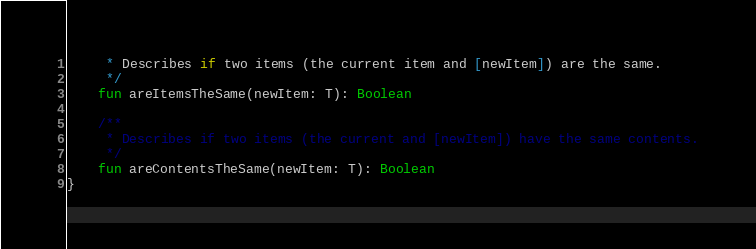<code> <loc_0><loc_0><loc_500><loc_500><_Kotlin_>     * Describes if two items (the current item and [newItem]) are the same.
     */
    fun areItemsTheSame(newItem: T): Boolean

    /**
     * Describes if two items (the current and [newItem]) have the same contents.
     */
    fun areContentsTheSame(newItem: T): Boolean
}
</code> 